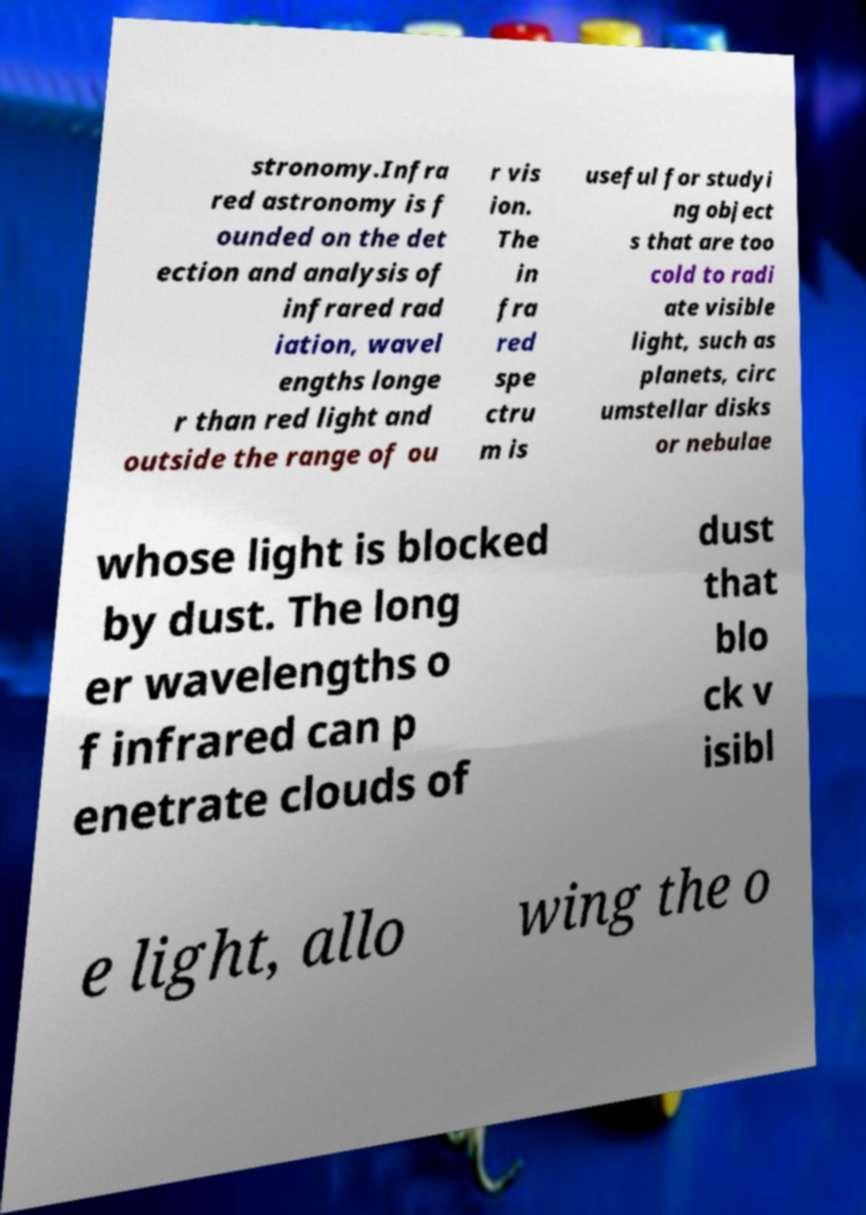For documentation purposes, I need the text within this image transcribed. Could you provide that? stronomy.Infra red astronomy is f ounded on the det ection and analysis of infrared rad iation, wavel engths longe r than red light and outside the range of ou r vis ion. The in fra red spe ctru m is useful for studyi ng object s that are too cold to radi ate visible light, such as planets, circ umstellar disks or nebulae whose light is blocked by dust. The long er wavelengths o f infrared can p enetrate clouds of dust that blo ck v isibl e light, allo wing the o 